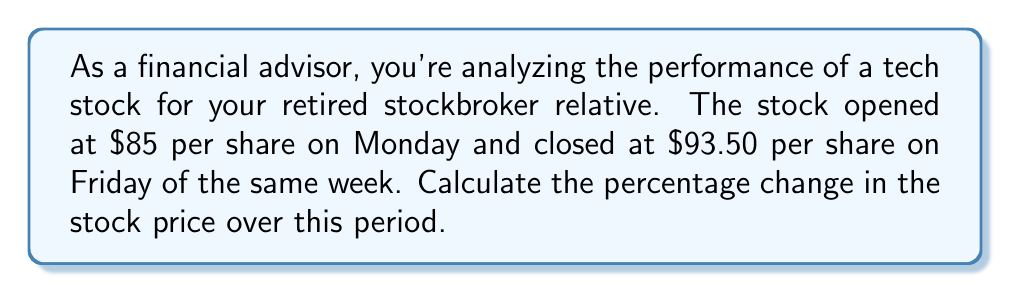Show me your answer to this math problem. To calculate the percentage change in stock price, we'll use the following formula:

$$ \text{Percentage Change} = \frac{\text{Change in Price}}{\text{Initial Price}} \times 100\% $$

Let's break this down step-by-step:

1. Determine the initial price and final price:
   - Initial price (Monday opening): $85
   - Final price (Friday closing): $93.50

2. Calculate the change in price:
   $$ \text{Change in Price} = \text{Final Price} - \text{Initial Price} $$
   $$ \text{Change in Price} = $93.50 - $85 = $8.50 $$

3. Apply the percentage change formula:
   $$ \text{Percentage Change} = \frac{$8.50}{$85} \times 100\% $$

4. Perform the division:
   $$ \text{Percentage Change} = 0.1 \times 100\% = 10\% $$

Therefore, the stock price increased by 10% over the week.
Answer: The percentage change in the stock price is an increase of 10%. 